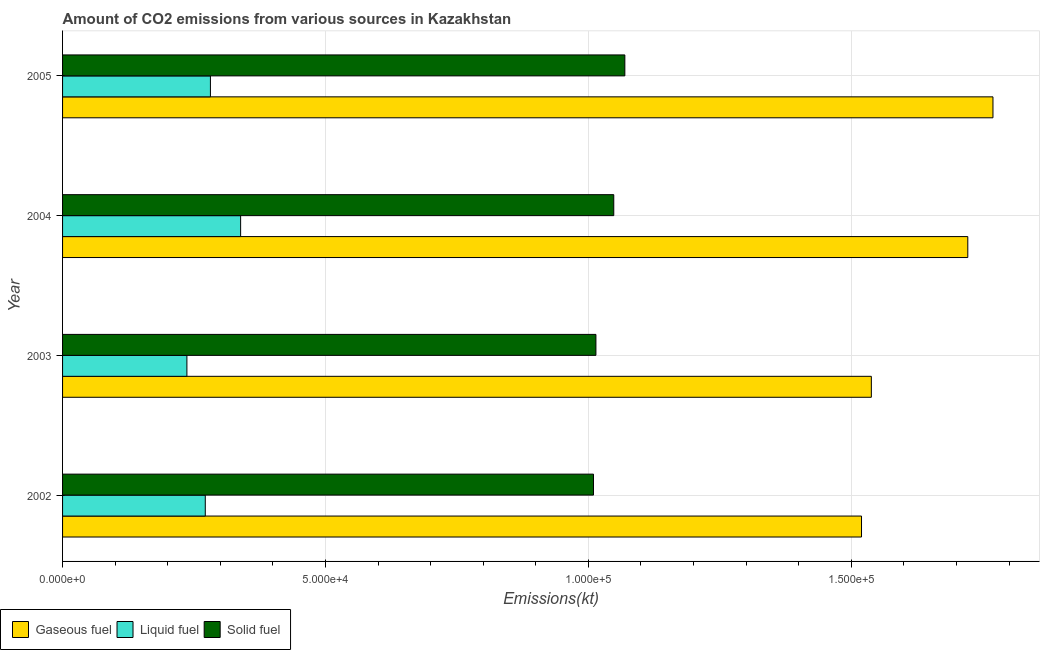What is the label of the 2nd group of bars from the top?
Provide a succinct answer. 2004. In how many cases, is the number of bars for a given year not equal to the number of legend labels?
Provide a short and direct response. 0. What is the amount of co2 emissions from solid fuel in 2003?
Offer a very short reply. 1.01e+05. Across all years, what is the maximum amount of co2 emissions from liquid fuel?
Offer a terse response. 3.39e+04. Across all years, what is the minimum amount of co2 emissions from gaseous fuel?
Offer a very short reply. 1.52e+05. In which year was the amount of co2 emissions from solid fuel maximum?
Keep it short and to the point. 2005. What is the total amount of co2 emissions from solid fuel in the graph?
Your response must be concise. 4.14e+05. What is the difference between the amount of co2 emissions from liquid fuel in 2002 and that in 2005?
Keep it short and to the point. -975.42. What is the difference between the amount of co2 emissions from liquid fuel in 2005 and the amount of co2 emissions from gaseous fuel in 2003?
Make the answer very short. -1.26e+05. What is the average amount of co2 emissions from gaseous fuel per year?
Offer a very short reply. 1.64e+05. In the year 2004, what is the difference between the amount of co2 emissions from solid fuel and amount of co2 emissions from liquid fuel?
Your response must be concise. 7.10e+04. In how many years, is the amount of co2 emissions from gaseous fuel greater than 100000 kt?
Make the answer very short. 4. Is the amount of co2 emissions from gaseous fuel in 2002 less than that in 2005?
Make the answer very short. Yes. What is the difference between the highest and the second highest amount of co2 emissions from liquid fuel?
Your answer should be very brief. 5746.19. What is the difference between the highest and the lowest amount of co2 emissions from solid fuel?
Provide a short and direct response. 5966.21. Is the sum of the amount of co2 emissions from solid fuel in 2002 and 2005 greater than the maximum amount of co2 emissions from liquid fuel across all years?
Provide a succinct answer. Yes. What does the 2nd bar from the top in 2004 represents?
Provide a succinct answer. Liquid fuel. What does the 2nd bar from the bottom in 2004 represents?
Provide a succinct answer. Liquid fuel. How many bars are there?
Keep it short and to the point. 12. Are all the bars in the graph horizontal?
Make the answer very short. Yes. Does the graph contain grids?
Offer a very short reply. Yes. How many legend labels are there?
Offer a terse response. 3. What is the title of the graph?
Provide a succinct answer. Amount of CO2 emissions from various sources in Kazakhstan. What is the label or title of the X-axis?
Keep it short and to the point. Emissions(kt). What is the Emissions(kt) of Gaseous fuel in 2002?
Ensure brevity in your answer.  1.52e+05. What is the Emissions(kt) in Liquid fuel in 2002?
Offer a terse response. 2.71e+04. What is the Emissions(kt) of Solid fuel in 2002?
Make the answer very short. 1.01e+05. What is the Emissions(kt) in Gaseous fuel in 2003?
Your response must be concise. 1.54e+05. What is the Emissions(kt) of Liquid fuel in 2003?
Your answer should be very brief. 2.36e+04. What is the Emissions(kt) in Solid fuel in 2003?
Provide a short and direct response. 1.01e+05. What is the Emissions(kt) in Gaseous fuel in 2004?
Provide a succinct answer. 1.72e+05. What is the Emissions(kt) of Liquid fuel in 2004?
Your answer should be compact. 3.39e+04. What is the Emissions(kt) in Solid fuel in 2004?
Your answer should be very brief. 1.05e+05. What is the Emissions(kt) of Gaseous fuel in 2005?
Provide a succinct answer. 1.77e+05. What is the Emissions(kt) of Liquid fuel in 2005?
Your answer should be very brief. 2.81e+04. What is the Emissions(kt) of Solid fuel in 2005?
Provide a short and direct response. 1.07e+05. Across all years, what is the maximum Emissions(kt) of Gaseous fuel?
Give a very brief answer. 1.77e+05. Across all years, what is the maximum Emissions(kt) in Liquid fuel?
Your answer should be very brief. 3.39e+04. Across all years, what is the maximum Emissions(kt) in Solid fuel?
Give a very brief answer. 1.07e+05. Across all years, what is the minimum Emissions(kt) in Gaseous fuel?
Ensure brevity in your answer.  1.52e+05. Across all years, what is the minimum Emissions(kt) of Liquid fuel?
Your response must be concise. 2.36e+04. Across all years, what is the minimum Emissions(kt) of Solid fuel?
Your response must be concise. 1.01e+05. What is the total Emissions(kt) in Gaseous fuel in the graph?
Offer a very short reply. 6.55e+05. What is the total Emissions(kt) of Liquid fuel in the graph?
Provide a short and direct response. 1.13e+05. What is the total Emissions(kt) in Solid fuel in the graph?
Keep it short and to the point. 4.14e+05. What is the difference between the Emissions(kt) in Gaseous fuel in 2002 and that in 2003?
Provide a short and direct response. -1870.17. What is the difference between the Emissions(kt) in Liquid fuel in 2002 and that in 2003?
Give a very brief answer. 3494.65. What is the difference between the Emissions(kt) of Solid fuel in 2002 and that in 2003?
Your answer should be very brief. -465.71. What is the difference between the Emissions(kt) in Gaseous fuel in 2002 and that in 2004?
Give a very brief answer. -2.02e+04. What is the difference between the Emissions(kt) of Liquid fuel in 2002 and that in 2004?
Provide a succinct answer. -6721.61. What is the difference between the Emissions(kt) in Solid fuel in 2002 and that in 2004?
Provide a short and direct response. -3857.68. What is the difference between the Emissions(kt) of Gaseous fuel in 2002 and that in 2005?
Ensure brevity in your answer.  -2.50e+04. What is the difference between the Emissions(kt) in Liquid fuel in 2002 and that in 2005?
Offer a terse response. -975.42. What is the difference between the Emissions(kt) of Solid fuel in 2002 and that in 2005?
Provide a short and direct response. -5966.21. What is the difference between the Emissions(kt) in Gaseous fuel in 2003 and that in 2004?
Your response must be concise. -1.83e+04. What is the difference between the Emissions(kt) in Liquid fuel in 2003 and that in 2004?
Make the answer very short. -1.02e+04. What is the difference between the Emissions(kt) of Solid fuel in 2003 and that in 2004?
Keep it short and to the point. -3391.97. What is the difference between the Emissions(kt) in Gaseous fuel in 2003 and that in 2005?
Your answer should be compact. -2.31e+04. What is the difference between the Emissions(kt) of Liquid fuel in 2003 and that in 2005?
Offer a very short reply. -4470.07. What is the difference between the Emissions(kt) in Solid fuel in 2003 and that in 2005?
Your answer should be very brief. -5500.5. What is the difference between the Emissions(kt) in Gaseous fuel in 2004 and that in 2005?
Your response must be concise. -4789.1. What is the difference between the Emissions(kt) in Liquid fuel in 2004 and that in 2005?
Offer a very short reply. 5746.19. What is the difference between the Emissions(kt) in Solid fuel in 2004 and that in 2005?
Provide a short and direct response. -2108.53. What is the difference between the Emissions(kt) of Gaseous fuel in 2002 and the Emissions(kt) of Liquid fuel in 2003?
Your answer should be compact. 1.28e+05. What is the difference between the Emissions(kt) in Gaseous fuel in 2002 and the Emissions(kt) in Solid fuel in 2003?
Your response must be concise. 5.05e+04. What is the difference between the Emissions(kt) in Liquid fuel in 2002 and the Emissions(kt) in Solid fuel in 2003?
Give a very brief answer. -7.43e+04. What is the difference between the Emissions(kt) of Gaseous fuel in 2002 and the Emissions(kt) of Liquid fuel in 2004?
Your answer should be very brief. 1.18e+05. What is the difference between the Emissions(kt) in Gaseous fuel in 2002 and the Emissions(kt) in Solid fuel in 2004?
Provide a short and direct response. 4.71e+04. What is the difference between the Emissions(kt) of Liquid fuel in 2002 and the Emissions(kt) of Solid fuel in 2004?
Your response must be concise. -7.77e+04. What is the difference between the Emissions(kt) of Gaseous fuel in 2002 and the Emissions(kt) of Liquid fuel in 2005?
Provide a short and direct response. 1.24e+05. What is the difference between the Emissions(kt) of Gaseous fuel in 2002 and the Emissions(kt) of Solid fuel in 2005?
Keep it short and to the point. 4.50e+04. What is the difference between the Emissions(kt) in Liquid fuel in 2002 and the Emissions(kt) in Solid fuel in 2005?
Offer a very short reply. -7.98e+04. What is the difference between the Emissions(kt) of Gaseous fuel in 2003 and the Emissions(kt) of Liquid fuel in 2004?
Provide a short and direct response. 1.20e+05. What is the difference between the Emissions(kt) in Gaseous fuel in 2003 and the Emissions(kt) in Solid fuel in 2004?
Your response must be concise. 4.90e+04. What is the difference between the Emissions(kt) of Liquid fuel in 2003 and the Emissions(kt) of Solid fuel in 2004?
Ensure brevity in your answer.  -8.12e+04. What is the difference between the Emissions(kt) of Gaseous fuel in 2003 and the Emissions(kt) of Liquid fuel in 2005?
Provide a short and direct response. 1.26e+05. What is the difference between the Emissions(kt) of Gaseous fuel in 2003 and the Emissions(kt) of Solid fuel in 2005?
Provide a succinct answer. 4.69e+04. What is the difference between the Emissions(kt) in Liquid fuel in 2003 and the Emissions(kt) in Solid fuel in 2005?
Provide a short and direct response. -8.33e+04. What is the difference between the Emissions(kt) in Gaseous fuel in 2004 and the Emissions(kt) in Liquid fuel in 2005?
Give a very brief answer. 1.44e+05. What is the difference between the Emissions(kt) in Gaseous fuel in 2004 and the Emissions(kt) in Solid fuel in 2005?
Offer a terse response. 6.52e+04. What is the difference between the Emissions(kt) of Liquid fuel in 2004 and the Emissions(kt) of Solid fuel in 2005?
Ensure brevity in your answer.  -7.31e+04. What is the average Emissions(kt) in Gaseous fuel per year?
Keep it short and to the point. 1.64e+05. What is the average Emissions(kt) in Liquid fuel per year?
Provide a succinct answer. 2.82e+04. What is the average Emissions(kt) of Solid fuel per year?
Offer a terse response. 1.04e+05. In the year 2002, what is the difference between the Emissions(kt) in Gaseous fuel and Emissions(kt) in Liquid fuel?
Your response must be concise. 1.25e+05. In the year 2002, what is the difference between the Emissions(kt) of Gaseous fuel and Emissions(kt) of Solid fuel?
Make the answer very short. 5.10e+04. In the year 2002, what is the difference between the Emissions(kt) in Liquid fuel and Emissions(kt) in Solid fuel?
Ensure brevity in your answer.  -7.38e+04. In the year 2003, what is the difference between the Emissions(kt) of Gaseous fuel and Emissions(kt) of Liquid fuel?
Offer a terse response. 1.30e+05. In the year 2003, what is the difference between the Emissions(kt) of Gaseous fuel and Emissions(kt) of Solid fuel?
Ensure brevity in your answer.  5.24e+04. In the year 2003, what is the difference between the Emissions(kt) of Liquid fuel and Emissions(kt) of Solid fuel?
Offer a terse response. -7.78e+04. In the year 2004, what is the difference between the Emissions(kt) in Gaseous fuel and Emissions(kt) in Liquid fuel?
Provide a succinct answer. 1.38e+05. In the year 2004, what is the difference between the Emissions(kt) of Gaseous fuel and Emissions(kt) of Solid fuel?
Your response must be concise. 6.73e+04. In the year 2004, what is the difference between the Emissions(kt) of Liquid fuel and Emissions(kt) of Solid fuel?
Make the answer very short. -7.10e+04. In the year 2005, what is the difference between the Emissions(kt) of Gaseous fuel and Emissions(kt) of Liquid fuel?
Ensure brevity in your answer.  1.49e+05. In the year 2005, what is the difference between the Emissions(kt) in Gaseous fuel and Emissions(kt) in Solid fuel?
Give a very brief answer. 7.00e+04. In the year 2005, what is the difference between the Emissions(kt) of Liquid fuel and Emissions(kt) of Solid fuel?
Your response must be concise. -7.88e+04. What is the ratio of the Emissions(kt) of Liquid fuel in 2002 to that in 2003?
Give a very brief answer. 1.15. What is the ratio of the Emissions(kt) in Solid fuel in 2002 to that in 2003?
Your response must be concise. 1. What is the ratio of the Emissions(kt) in Gaseous fuel in 2002 to that in 2004?
Offer a very short reply. 0.88. What is the ratio of the Emissions(kt) of Liquid fuel in 2002 to that in 2004?
Your answer should be compact. 0.8. What is the ratio of the Emissions(kt) in Solid fuel in 2002 to that in 2004?
Offer a terse response. 0.96. What is the ratio of the Emissions(kt) of Gaseous fuel in 2002 to that in 2005?
Ensure brevity in your answer.  0.86. What is the ratio of the Emissions(kt) of Liquid fuel in 2002 to that in 2005?
Provide a short and direct response. 0.97. What is the ratio of the Emissions(kt) in Solid fuel in 2002 to that in 2005?
Offer a terse response. 0.94. What is the ratio of the Emissions(kt) of Gaseous fuel in 2003 to that in 2004?
Make the answer very short. 0.89. What is the ratio of the Emissions(kt) in Liquid fuel in 2003 to that in 2004?
Ensure brevity in your answer.  0.7. What is the ratio of the Emissions(kt) of Solid fuel in 2003 to that in 2004?
Your answer should be compact. 0.97. What is the ratio of the Emissions(kt) in Gaseous fuel in 2003 to that in 2005?
Provide a short and direct response. 0.87. What is the ratio of the Emissions(kt) in Liquid fuel in 2003 to that in 2005?
Provide a succinct answer. 0.84. What is the ratio of the Emissions(kt) of Solid fuel in 2003 to that in 2005?
Ensure brevity in your answer.  0.95. What is the ratio of the Emissions(kt) of Gaseous fuel in 2004 to that in 2005?
Your response must be concise. 0.97. What is the ratio of the Emissions(kt) of Liquid fuel in 2004 to that in 2005?
Provide a short and direct response. 1.2. What is the ratio of the Emissions(kt) in Solid fuel in 2004 to that in 2005?
Your answer should be compact. 0.98. What is the difference between the highest and the second highest Emissions(kt) of Gaseous fuel?
Make the answer very short. 4789.1. What is the difference between the highest and the second highest Emissions(kt) of Liquid fuel?
Your answer should be very brief. 5746.19. What is the difference between the highest and the second highest Emissions(kt) of Solid fuel?
Give a very brief answer. 2108.53. What is the difference between the highest and the lowest Emissions(kt) in Gaseous fuel?
Offer a terse response. 2.50e+04. What is the difference between the highest and the lowest Emissions(kt) in Liquid fuel?
Offer a very short reply. 1.02e+04. What is the difference between the highest and the lowest Emissions(kt) of Solid fuel?
Your answer should be compact. 5966.21. 